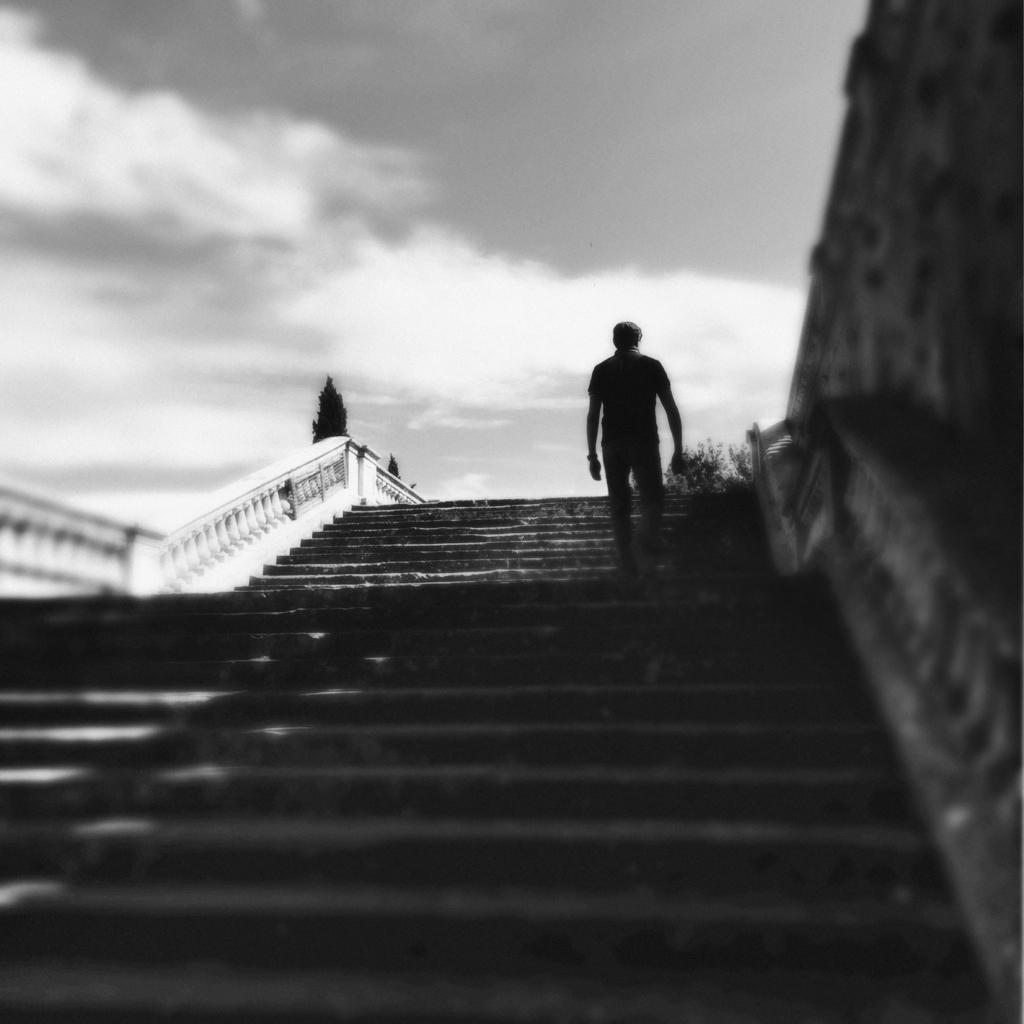What is located in front of the person in the image? There are steps in front in the image. Can you describe the person in the image? There is a person standing in the image. What can be seen in the background of the image? The sky is visible in the background of the image. How would you describe the weather based on the sky in the image? The sky appears to be cloudy in the image. What is on the right side of the image? There is a wall on the right side of the image. What grade does the person in the image receive for their body posture? There is no indication of a grade or evaluation of the person's body posture in the image. What impulse causes the wall to be on the right side of the image? The image is a static representation and does not depict any impulses or forces acting on the wall. 